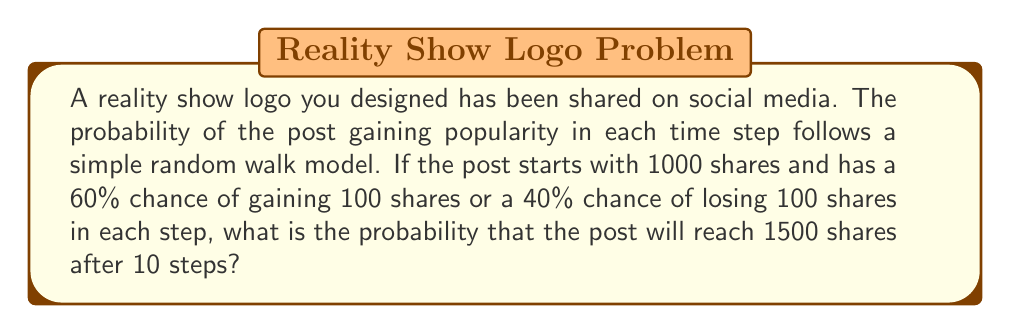Show me your answer to this math problem. Let's approach this step-by-step using the properties of random walks:

1) First, we need to calculate the number of steps needed to reach 1500 shares:
   $$(1500 - 1000) / 100 = 5$$ steps upward

2) In a random walk, the probability of reaching a specific point after n steps is given by the binomial distribution:

   $$P(X = k) = \binom{n}{k} p^k (1-p)^{n-k}$$

   Where:
   - n is the total number of steps (10 in this case)
   - k is the number of successful steps needed (5 in this case)
   - p is the probability of success on each step (0.6 in this case)

3) Plugging in our values:

   $$P(X = 5) = \binom{10}{5} (0.6)^5 (0.4)^{10-5}$$

4) Calculate the binomial coefficient:
   
   $$\binom{10}{5} = \frac{10!}{5!(10-5)!} = 252$$

5) Now we can calculate:

   $$252 * (0.6)^5 * (0.4)^5 = 252 * 0.07776 * 0.01024 = 0.2001$$

Therefore, the probability of the post reaching exactly 1500 shares after 10 steps is approximately 0.2001 or 20.01%.
Answer: 0.2001 